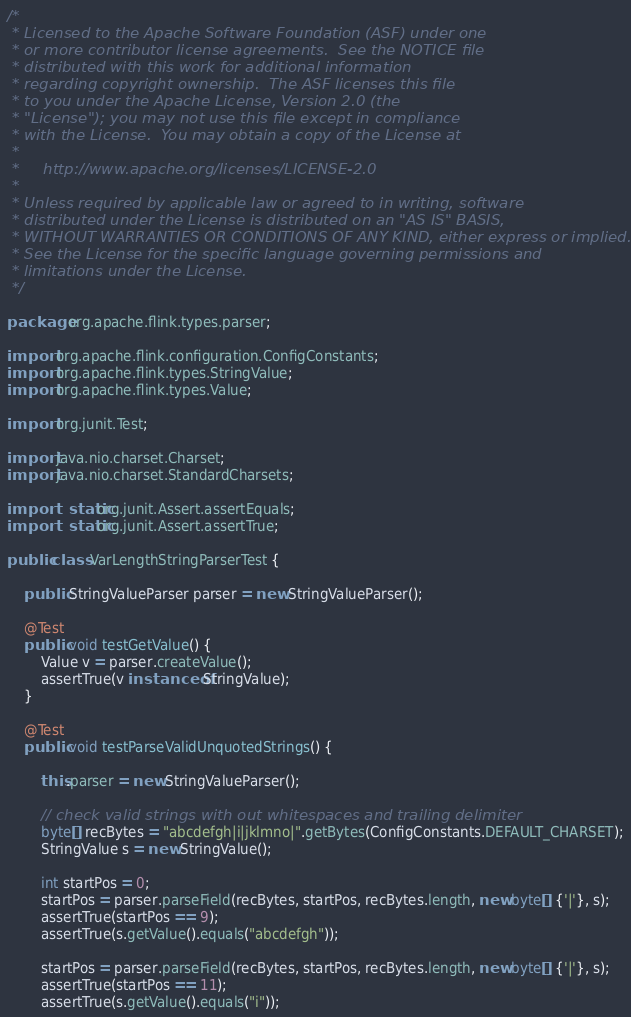Convert code to text. <code><loc_0><loc_0><loc_500><loc_500><_Java_>/*
 * Licensed to the Apache Software Foundation (ASF) under one
 * or more contributor license agreements.  See the NOTICE file
 * distributed with this work for additional information
 * regarding copyright ownership.  The ASF licenses this file
 * to you under the Apache License, Version 2.0 (the
 * "License"); you may not use this file except in compliance
 * with the License.  You may obtain a copy of the License at
 *
 *     http://www.apache.org/licenses/LICENSE-2.0
 *
 * Unless required by applicable law or agreed to in writing, software
 * distributed under the License is distributed on an "AS IS" BASIS,
 * WITHOUT WARRANTIES OR CONDITIONS OF ANY KIND, either express or implied.
 * See the License for the specific language governing permissions and
 * limitations under the License.
 */

package org.apache.flink.types.parser;

import org.apache.flink.configuration.ConfigConstants;
import org.apache.flink.types.StringValue;
import org.apache.flink.types.Value;

import org.junit.Test;

import java.nio.charset.Charset;
import java.nio.charset.StandardCharsets;

import static org.junit.Assert.assertEquals;
import static org.junit.Assert.assertTrue;

public class VarLengthStringParserTest {

    public StringValueParser parser = new StringValueParser();

    @Test
    public void testGetValue() {
        Value v = parser.createValue();
        assertTrue(v instanceof StringValue);
    }

    @Test
    public void testParseValidUnquotedStrings() {

        this.parser = new StringValueParser();

        // check valid strings with out whitespaces and trailing delimiter
        byte[] recBytes = "abcdefgh|i|jklmno|".getBytes(ConfigConstants.DEFAULT_CHARSET);
        StringValue s = new StringValue();

        int startPos = 0;
        startPos = parser.parseField(recBytes, startPos, recBytes.length, new byte[] {'|'}, s);
        assertTrue(startPos == 9);
        assertTrue(s.getValue().equals("abcdefgh"));

        startPos = parser.parseField(recBytes, startPos, recBytes.length, new byte[] {'|'}, s);
        assertTrue(startPos == 11);
        assertTrue(s.getValue().equals("i"));
</code> 